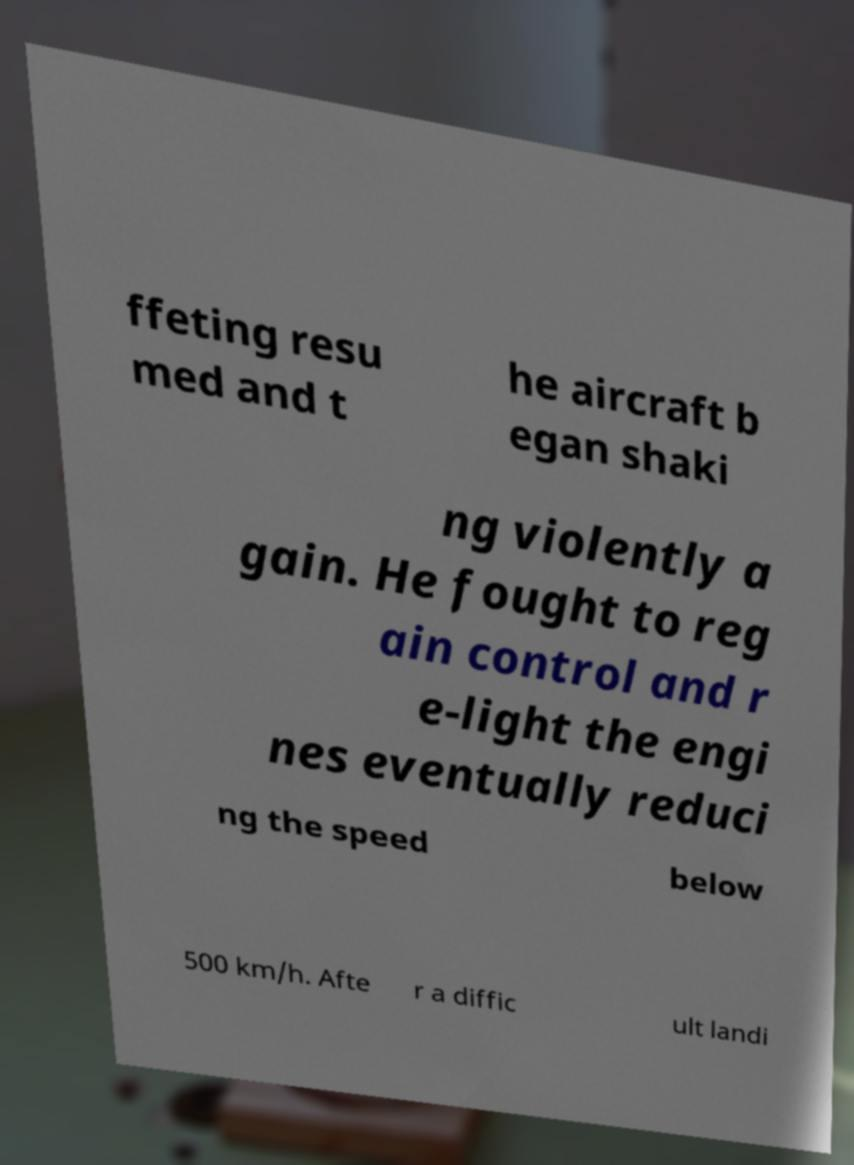I need the written content from this picture converted into text. Can you do that? ffeting resu med and t he aircraft b egan shaki ng violently a gain. He fought to reg ain control and r e-light the engi nes eventually reduci ng the speed below 500 km/h. Afte r a diffic ult landi 